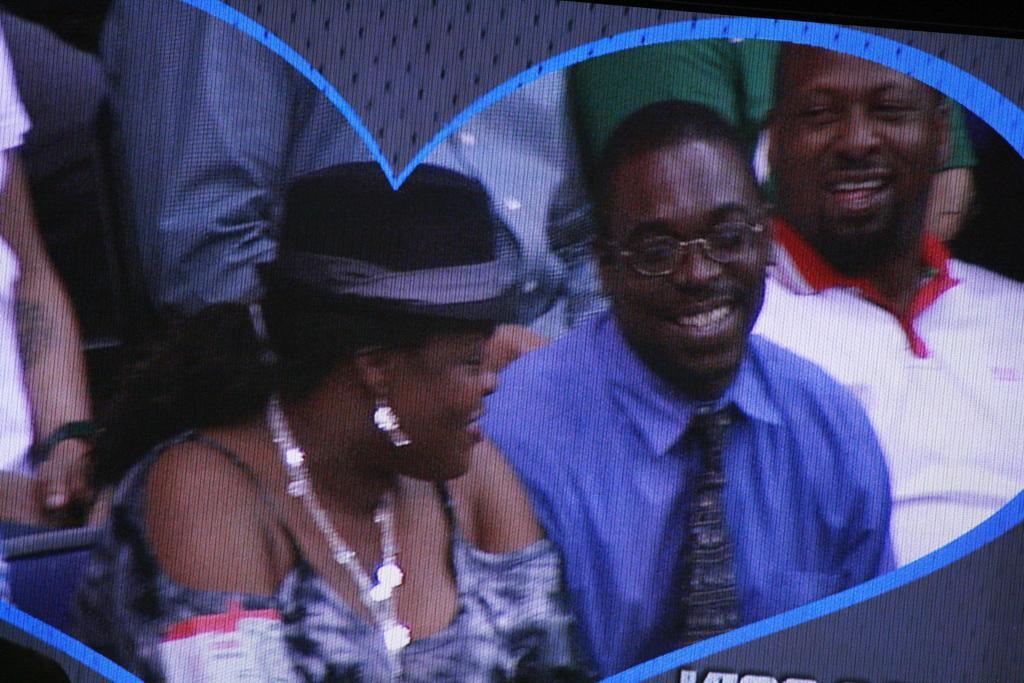How would you summarize this image in a sentence or two? In this image, we can see a few people sitting. Among them, there is a woman. 